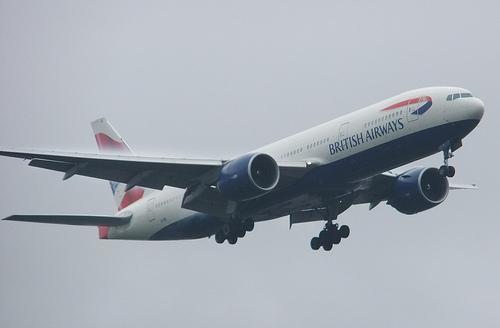How many planes are seen?
Give a very brief answer. 1. 